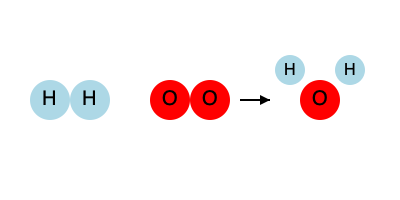Balance the following chemical equation for the formation of water, given the molecule diagrams:

$\text{H}_2 + \text{O}_2 \rightarrow \text{H}_2\text{O}$

How many molecules of $\text{H}_2\text{O}$ are produced in the balanced equation? To balance this equation, we need to follow these steps:

1. Count the atoms on each side of the equation:
   - Left side: 2 H atoms, 2 O atoms
   - Right side: 2 H atoms, 1 O atom

2. The O atoms are not balanced. We need 2 O atoms on the right side.
   To achieve this, we multiply $\text{H}_2\text{O}$ by 2:
   
   $\text{H}_2 + \text{O}_2 \rightarrow 2\text{H}_2\text{O}$

3. Now we have:
   - Left side: 2 H atoms, 2 O atoms
   - Right side: 4 H atoms, 2 O atoms

4. The H atoms are not balanced. We need 4 H atoms on the left side.
   To achieve this, we multiply $\text{H}_2$ by 2:
   
   $2\text{H}_2 + \text{O}_2 \rightarrow 2\text{H}_2\text{O}$

5. Final atom count:
   - Left side: 4 H atoms, 2 O atoms
   - Right side: 4 H atoms, 2 O atoms

The equation is now balanced. We can see that 2 molecules of $\text{H}_2\text{O}$ are produced in the balanced equation.
Answer: 2 